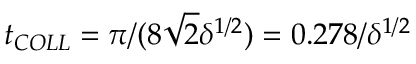Convert formula to latex. <formula><loc_0><loc_0><loc_500><loc_500>t _ { C O L L } = \pi / ( 8 \sqrt { 2 } \delta ^ { 1 / 2 } ) = 0 . 2 7 8 / \delta ^ { 1 / 2 }</formula> 